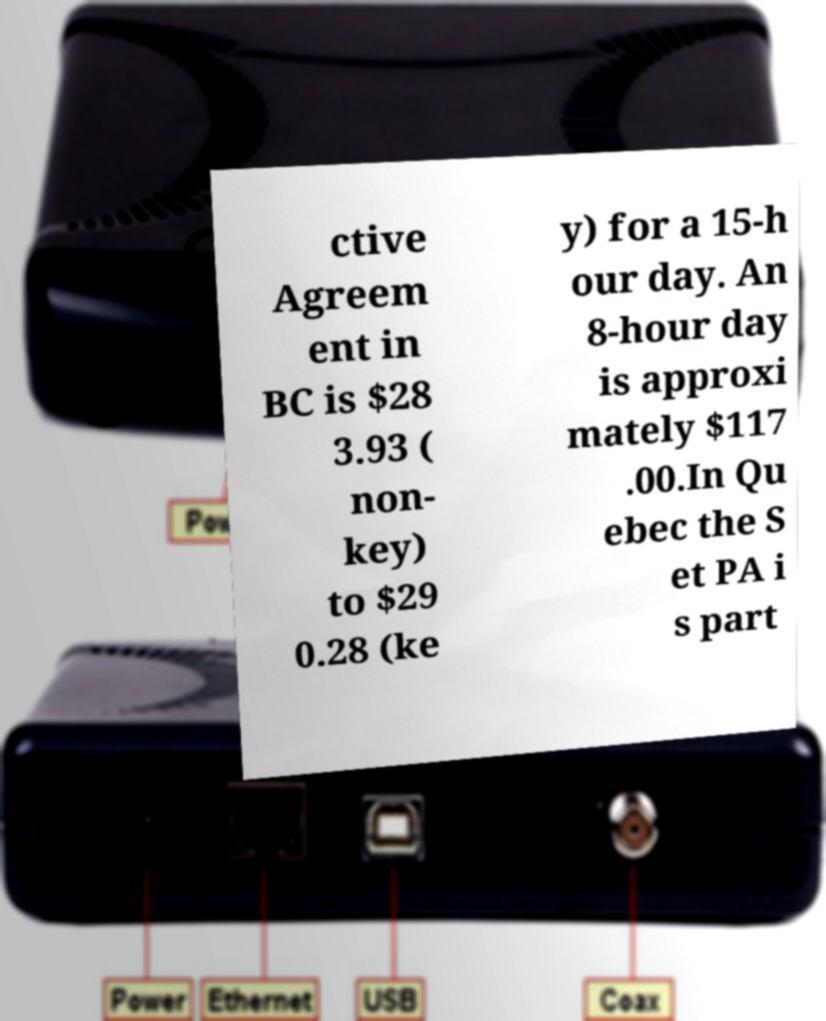Please identify and transcribe the text found in this image. ctive Agreem ent in BC is $28 3.93 ( non- key) to $29 0.28 (ke y) for a 15-h our day. An 8-hour day is approxi mately $117 .00.In Qu ebec the S et PA i s part 